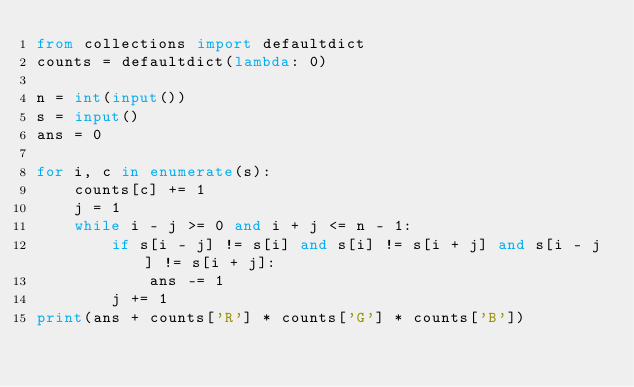<code> <loc_0><loc_0><loc_500><loc_500><_Python_>from collections import defaultdict
counts = defaultdict(lambda: 0)

n = int(input())
s = input()
ans = 0

for i, c in enumerate(s):
    counts[c] += 1
    j = 1
    while i - j >= 0 and i + j <= n - 1:
        if s[i - j] != s[i] and s[i] != s[i + j] and s[i - j] != s[i + j]:
            ans -= 1
        j += 1
print(ans + counts['R'] * counts['G'] * counts['B'])
</code> 